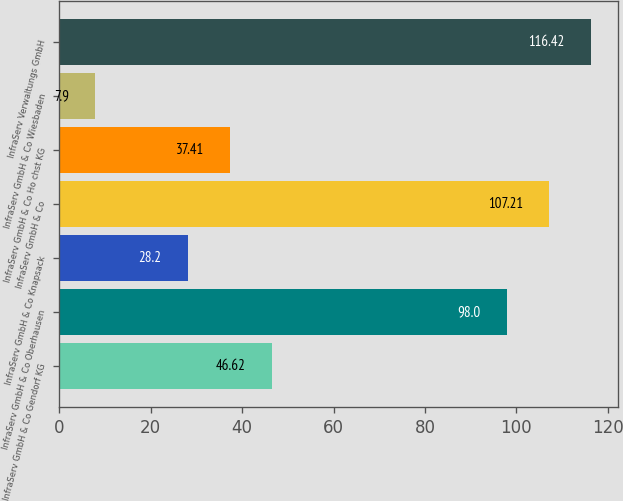Convert chart to OTSL. <chart><loc_0><loc_0><loc_500><loc_500><bar_chart><fcel>InfraServ GmbH & Co Gendorf KG<fcel>InfraServ GmbH & Co Oberhausen<fcel>InfraServ GmbH & Co Knapsack<fcel>InfraServ GmbH & Co<fcel>InfraServ GmbH & Co Ho chst KG<fcel>InfraServ GmbH & Co Wiesbaden<fcel>InfraServ Verwaltungs GmbH<nl><fcel>46.62<fcel>98<fcel>28.2<fcel>107.21<fcel>37.41<fcel>7.9<fcel>116.42<nl></chart> 